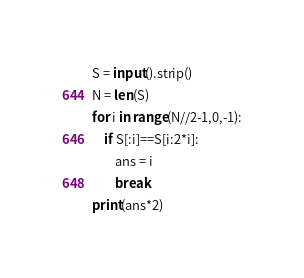<code> <loc_0><loc_0><loc_500><loc_500><_Python_>S = input().strip()
N = len(S)
for i in range(N//2-1,0,-1):
    if S[:i]==S[i:2*i]:
        ans = i
        break
print(ans*2)</code> 